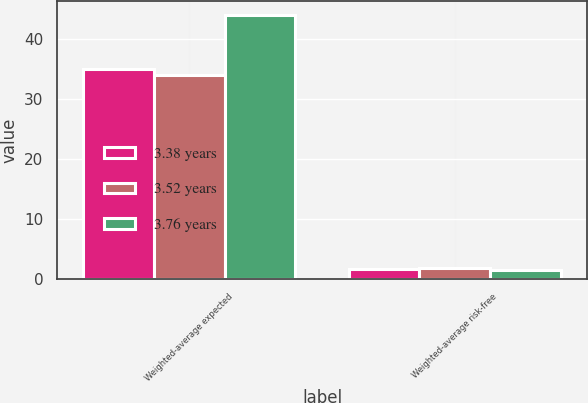<chart> <loc_0><loc_0><loc_500><loc_500><stacked_bar_chart><ecel><fcel>Weighted-average expected<fcel>Weighted-average risk-free<nl><fcel>3.38 years<fcel>35<fcel>1.62<nl><fcel>3.52 years<fcel>34<fcel>1.85<nl><fcel>3.76 years<fcel>44<fcel>1.47<nl></chart> 